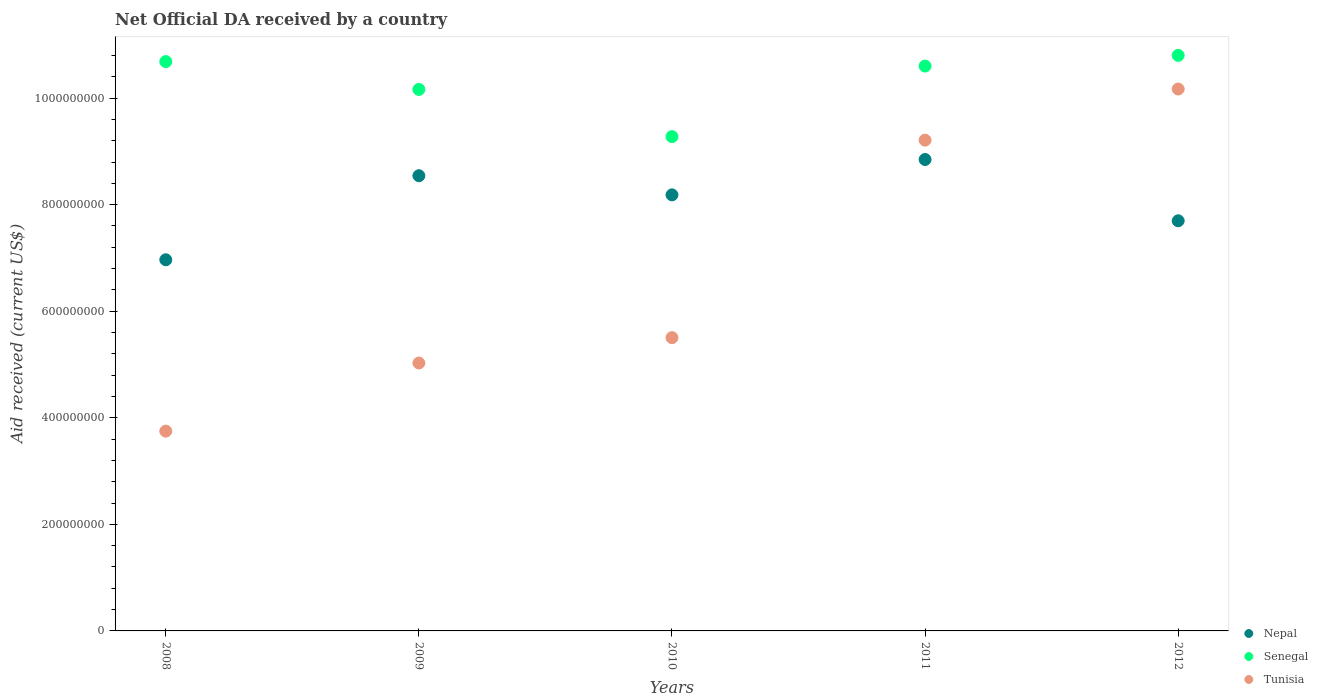What is the net official development assistance aid received in Tunisia in 2011?
Provide a short and direct response. 9.21e+08. Across all years, what is the maximum net official development assistance aid received in Senegal?
Offer a terse response. 1.08e+09. Across all years, what is the minimum net official development assistance aid received in Nepal?
Make the answer very short. 6.97e+08. What is the total net official development assistance aid received in Senegal in the graph?
Ensure brevity in your answer.  5.15e+09. What is the difference between the net official development assistance aid received in Nepal in 2008 and that in 2009?
Provide a short and direct response. -1.58e+08. What is the difference between the net official development assistance aid received in Nepal in 2011 and the net official development assistance aid received in Tunisia in 2010?
Provide a succinct answer. 3.34e+08. What is the average net official development assistance aid received in Nepal per year?
Offer a terse response. 8.05e+08. In the year 2011, what is the difference between the net official development assistance aid received in Senegal and net official development assistance aid received in Nepal?
Give a very brief answer. 1.75e+08. In how many years, is the net official development assistance aid received in Nepal greater than 720000000 US$?
Give a very brief answer. 4. What is the ratio of the net official development assistance aid received in Tunisia in 2009 to that in 2010?
Offer a very short reply. 0.91. What is the difference between the highest and the second highest net official development assistance aid received in Tunisia?
Provide a succinct answer. 9.59e+07. What is the difference between the highest and the lowest net official development assistance aid received in Senegal?
Offer a terse response. 1.52e+08. In how many years, is the net official development assistance aid received in Tunisia greater than the average net official development assistance aid received in Tunisia taken over all years?
Your answer should be compact. 2. Is the sum of the net official development assistance aid received in Senegal in 2011 and 2012 greater than the maximum net official development assistance aid received in Tunisia across all years?
Provide a succinct answer. Yes. Is it the case that in every year, the sum of the net official development assistance aid received in Nepal and net official development assistance aid received in Tunisia  is greater than the net official development assistance aid received in Senegal?
Offer a very short reply. Yes. Is the net official development assistance aid received in Tunisia strictly greater than the net official development assistance aid received in Nepal over the years?
Ensure brevity in your answer.  No. Is the net official development assistance aid received in Tunisia strictly less than the net official development assistance aid received in Nepal over the years?
Make the answer very short. No. How many dotlines are there?
Your answer should be very brief. 3. How many years are there in the graph?
Make the answer very short. 5. What is the difference between two consecutive major ticks on the Y-axis?
Give a very brief answer. 2.00e+08. Does the graph contain grids?
Keep it short and to the point. No. Where does the legend appear in the graph?
Ensure brevity in your answer.  Bottom right. What is the title of the graph?
Offer a terse response. Net Official DA received by a country. Does "Nicaragua" appear as one of the legend labels in the graph?
Your answer should be very brief. No. What is the label or title of the Y-axis?
Give a very brief answer. Aid received (current US$). What is the Aid received (current US$) of Nepal in 2008?
Give a very brief answer. 6.97e+08. What is the Aid received (current US$) in Senegal in 2008?
Give a very brief answer. 1.07e+09. What is the Aid received (current US$) in Tunisia in 2008?
Give a very brief answer. 3.75e+08. What is the Aid received (current US$) in Nepal in 2009?
Ensure brevity in your answer.  8.54e+08. What is the Aid received (current US$) in Senegal in 2009?
Keep it short and to the point. 1.02e+09. What is the Aid received (current US$) in Tunisia in 2009?
Ensure brevity in your answer.  5.03e+08. What is the Aid received (current US$) of Nepal in 2010?
Your response must be concise. 8.18e+08. What is the Aid received (current US$) of Senegal in 2010?
Offer a very short reply. 9.28e+08. What is the Aid received (current US$) of Tunisia in 2010?
Offer a terse response. 5.50e+08. What is the Aid received (current US$) of Nepal in 2011?
Keep it short and to the point. 8.85e+08. What is the Aid received (current US$) of Senegal in 2011?
Offer a terse response. 1.06e+09. What is the Aid received (current US$) of Tunisia in 2011?
Provide a short and direct response. 9.21e+08. What is the Aid received (current US$) in Nepal in 2012?
Your answer should be compact. 7.70e+08. What is the Aid received (current US$) of Senegal in 2012?
Ensure brevity in your answer.  1.08e+09. What is the Aid received (current US$) of Tunisia in 2012?
Ensure brevity in your answer.  1.02e+09. Across all years, what is the maximum Aid received (current US$) in Nepal?
Keep it short and to the point. 8.85e+08. Across all years, what is the maximum Aid received (current US$) in Senegal?
Keep it short and to the point. 1.08e+09. Across all years, what is the maximum Aid received (current US$) in Tunisia?
Ensure brevity in your answer.  1.02e+09. Across all years, what is the minimum Aid received (current US$) in Nepal?
Your answer should be compact. 6.97e+08. Across all years, what is the minimum Aid received (current US$) in Senegal?
Provide a short and direct response. 9.28e+08. Across all years, what is the minimum Aid received (current US$) of Tunisia?
Make the answer very short. 3.75e+08. What is the total Aid received (current US$) in Nepal in the graph?
Make the answer very short. 4.02e+09. What is the total Aid received (current US$) in Senegal in the graph?
Give a very brief answer. 5.15e+09. What is the total Aid received (current US$) of Tunisia in the graph?
Keep it short and to the point. 3.37e+09. What is the difference between the Aid received (current US$) in Nepal in 2008 and that in 2009?
Give a very brief answer. -1.58e+08. What is the difference between the Aid received (current US$) of Senegal in 2008 and that in 2009?
Your response must be concise. 5.23e+07. What is the difference between the Aid received (current US$) in Tunisia in 2008 and that in 2009?
Make the answer very short. -1.28e+08. What is the difference between the Aid received (current US$) of Nepal in 2008 and that in 2010?
Give a very brief answer. -1.22e+08. What is the difference between the Aid received (current US$) in Senegal in 2008 and that in 2010?
Your response must be concise. 1.41e+08. What is the difference between the Aid received (current US$) in Tunisia in 2008 and that in 2010?
Provide a succinct answer. -1.75e+08. What is the difference between the Aid received (current US$) in Nepal in 2008 and that in 2011?
Provide a succinct answer. -1.88e+08. What is the difference between the Aid received (current US$) of Senegal in 2008 and that in 2011?
Keep it short and to the point. 8.43e+06. What is the difference between the Aid received (current US$) of Tunisia in 2008 and that in 2011?
Make the answer very short. -5.46e+08. What is the difference between the Aid received (current US$) in Nepal in 2008 and that in 2012?
Your answer should be very brief. -7.32e+07. What is the difference between the Aid received (current US$) in Senegal in 2008 and that in 2012?
Your response must be concise. -1.17e+07. What is the difference between the Aid received (current US$) in Tunisia in 2008 and that in 2012?
Your response must be concise. -6.42e+08. What is the difference between the Aid received (current US$) of Nepal in 2009 and that in 2010?
Offer a very short reply. 3.60e+07. What is the difference between the Aid received (current US$) of Senegal in 2009 and that in 2010?
Make the answer very short. 8.86e+07. What is the difference between the Aid received (current US$) in Tunisia in 2009 and that in 2010?
Ensure brevity in your answer.  -4.76e+07. What is the difference between the Aid received (current US$) of Nepal in 2009 and that in 2011?
Offer a very short reply. -3.04e+07. What is the difference between the Aid received (current US$) of Senegal in 2009 and that in 2011?
Keep it short and to the point. -4.38e+07. What is the difference between the Aid received (current US$) of Tunisia in 2009 and that in 2011?
Offer a very short reply. -4.18e+08. What is the difference between the Aid received (current US$) of Nepal in 2009 and that in 2012?
Ensure brevity in your answer.  8.46e+07. What is the difference between the Aid received (current US$) of Senegal in 2009 and that in 2012?
Offer a terse response. -6.40e+07. What is the difference between the Aid received (current US$) of Tunisia in 2009 and that in 2012?
Make the answer very short. -5.14e+08. What is the difference between the Aid received (current US$) of Nepal in 2010 and that in 2011?
Your answer should be very brief. -6.64e+07. What is the difference between the Aid received (current US$) in Senegal in 2010 and that in 2011?
Your answer should be compact. -1.32e+08. What is the difference between the Aid received (current US$) of Tunisia in 2010 and that in 2011?
Your response must be concise. -3.71e+08. What is the difference between the Aid received (current US$) of Nepal in 2010 and that in 2012?
Provide a succinct answer. 4.86e+07. What is the difference between the Aid received (current US$) in Senegal in 2010 and that in 2012?
Make the answer very short. -1.52e+08. What is the difference between the Aid received (current US$) of Tunisia in 2010 and that in 2012?
Give a very brief answer. -4.67e+08. What is the difference between the Aid received (current US$) of Nepal in 2011 and that in 2012?
Your answer should be compact. 1.15e+08. What is the difference between the Aid received (current US$) of Senegal in 2011 and that in 2012?
Give a very brief answer. -2.01e+07. What is the difference between the Aid received (current US$) in Tunisia in 2011 and that in 2012?
Give a very brief answer. -9.59e+07. What is the difference between the Aid received (current US$) in Nepal in 2008 and the Aid received (current US$) in Senegal in 2009?
Your answer should be compact. -3.20e+08. What is the difference between the Aid received (current US$) of Nepal in 2008 and the Aid received (current US$) of Tunisia in 2009?
Offer a terse response. 1.94e+08. What is the difference between the Aid received (current US$) of Senegal in 2008 and the Aid received (current US$) of Tunisia in 2009?
Your answer should be very brief. 5.66e+08. What is the difference between the Aid received (current US$) in Nepal in 2008 and the Aid received (current US$) in Senegal in 2010?
Ensure brevity in your answer.  -2.31e+08. What is the difference between the Aid received (current US$) in Nepal in 2008 and the Aid received (current US$) in Tunisia in 2010?
Keep it short and to the point. 1.46e+08. What is the difference between the Aid received (current US$) in Senegal in 2008 and the Aid received (current US$) in Tunisia in 2010?
Give a very brief answer. 5.18e+08. What is the difference between the Aid received (current US$) in Nepal in 2008 and the Aid received (current US$) in Senegal in 2011?
Offer a terse response. -3.64e+08. What is the difference between the Aid received (current US$) of Nepal in 2008 and the Aid received (current US$) of Tunisia in 2011?
Give a very brief answer. -2.25e+08. What is the difference between the Aid received (current US$) in Senegal in 2008 and the Aid received (current US$) in Tunisia in 2011?
Provide a short and direct response. 1.47e+08. What is the difference between the Aid received (current US$) in Nepal in 2008 and the Aid received (current US$) in Senegal in 2012?
Ensure brevity in your answer.  -3.84e+08. What is the difference between the Aid received (current US$) of Nepal in 2008 and the Aid received (current US$) of Tunisia in 2012?
Keep it short and to the point. -3.20e+08. What is the difference between the Aid received (current US$) in Senegal in 2008 and the Aid received (current US$) in Tunisia in 2012?
Make the answer very short. 5.15e+07. What is the difference between the Aid received (current US$) in Nepal in 2009 and the Aid received (current US$) in Senegal in 2010?
Make the answer very short. -7.34e+07. What is the difference between the Aid received (current US$) of Nepal in 2009 and the Aid received (current US$) of Tunisia in 2010?
Your answer should be very brief. 3.04e+08. What is the difference between the Aid received (current US$) in Senegal in 2009 and the Aid received (current US$) in Tunisia in 2010?
Make the answer very short. 4.66e+08. What is the difference between the Aid received (current US$) in Nepal in 2009 and the Aid received (current US$) in Senegal in 2011?
Ensure brevity in your answer.  -2.06e+08. What is the difference between the Aid received (current US$) of Nepal in 2009 and the Aid received (current US$) of Tunisia in 2011?
Give a very brief answer. -6.68e+07. What is the difference between the Aid received (current US$) of Senegal in 2009 and the Aid received (current US$) of Tunisia in 2011?
Provide a short and direct response. 9.52e+07. What is the difference between the Aid received (current US$) in Nepal in 2009 and the Aid received (current US$) in Senegal in 2012?
Make the answer very short. -2.26e+08. What is the difference between the Aid received (current US$) of Nepal in 2009 and the Aid received (current US$) of Tunisia in 2012?
Offer a terse response. -1.63e+08. What is the difference between the Aid received (current US$) in Senegal in 2009 and the Aid received (current US$) in Tunisia in 2012?
Offer a very short reply. -7.90e+05. What is the difference between the Aid received (current US$) in Nepal in 2010 and the Aid received (current US$) in Senegal in 2011?
Keep it short and to the point. -2.42e+08. What is the difference between the Aid received (current US$) in Nepal in 2010 and the Aid received (current US$) in Tunisia in 2011?
Provide a succinct answer. -1.03e+08. What is the difference between the Aid received (current US$) of Senegal in 2010 and the Aid received (current US$) of Tunisia in 2011?
Provide a short and direct response. 6.60e+06. What is the difference between the Aid received (current US$) in Nepal in 2010 and the Aid received (current US$) in Senegal in 2012?
Provide a short and direct response. -2.62e+08. What is the difference between the Aid received (current US$) in Nepal in 2010 and the Aid received (current US$) in Tunisia in 2012?
Your answer should be very brief. -1.99e+08. What is the difference between the Aid received (current US$) of Senegal in 2010 and the Aid received (current US$) of Tunisia in 2012?
Your answer should be very brief. -8.93e+07. What is the difference between the Aid received (current US$) in Nepal in 2011 and the Aid received (current US$) in Senegal in 2012?
Ensure brevity in your answer.  -1.95e+08. What is the difference between the Aid received (current US$) in Nepal in 2011 and the Aid received (current US$) in Tunisia in 2012?
Your answer should be very brief. -1.32e+08. What is the difference between the Aid received (current US$) of Senegal in 2011 and the Aid received (current US$) of Tunisia in 2012?
Provide a succinct answer. 4.31e+07. What is the average Aid received (current US$) of Nepal per year?
Ensure brevity in your answer.  8.05e+08. What is the average Aid received (current US$) in Senegal per year?
Offer a terse response. 1.03e+09. What is the average Aid received (current US$) of Tunisia per year?
Provide a short and direct response. 6.73e+08. In the year 2008, what is the difference between the Aid received (current US$) of Nepal and Aid received (current US$) of Senegal?
Make the answer very short. -3.72e+08. In the year 2008, what is the difference between the Aid received (current US$) of Nepal and Aid received (current US$) of Tunisia?
Keep it short and to the point. 3.22e+08. In the year 2008, what is the difference between the Aid received (current US$) in Senegal and Aid received (current US$) in Tunisia?
Offer a very short reply. 6.94e+08. In the year 2009, what is the difference between the Aid received (current US$) of Nepal and Aid received (current US$) of Senegal?
Provide a short and direct response. -1.62e+08. In the year 2009, what is the difference between the Aid received (current US$) of Nepal and Aid received (current US$) of Tunisia?
Offer a very short reply. 3.52e+08. In the year 2009, what is the difference between the Aid received (current US$) in Senegal and Aid received (current US$) in Tunisia?
Provide a succinct answer. 5.13e+08. In the year 2010, what is the difference between the Aid received (current US$) of Nepal and Aid received (current US$) of Senegal?
Your answer should be compact. -1.09e+08. In the year 2010, what is the difference between the Aid received (current US$) of Nepal and Aid received (current US$) of Tunisia?
Ensure brevity in your answer.  2.68e+08. In the year 2010, what is the difference between the Aid received (current US$) in Senegal and Aid received (current US$) in Tunisia?
Your response must be concise. 3.77e+08. In the year 2011, what is the difference between the Aid received (current US$) of Nepal and Aid received (current US$) of Senegal?
Provide a short and direct response. -1.75e+08. In the year 2011, what is the difference between the Aid received (current US$) in Nepal and Aid received (current US$) in Tunisia?
Your answer should be very brief. -3.63e+07. In the year 2011, what is the difference between the Aid received (current US$) in Senegal and Aid received (current US$) in Tunisia?
Your answer should be very brief. 1.39e+08. In the year 2012, what is the difference between the Aid received (current US$) of Nepal and Aid received (current US$) of Senegal?
Give a very brief answer. -3.10e+08. In the year 2012, what is the difference between the Aid received (current US$) of Nepal and Aid received (current US$) of Tunisia?
Make the answer very short. -2.47e+08. In the year 2012, what is the difference between the Aid received (current US$) of Senegal and Aid received (current US$) of Tunisia?
Provide a short and direct response. 6.32e+07. What is the ratio of the Aid received (current US$) in Nepal in 2008 to that in 2009?
Your response must be concise. 0.82. What is the ratio of the Aid received (current US$) of Senegal in 2008 to that in 2009?
Provide a succinct answer. 1.05. What is the ratio of the Aid received (current US$) of Tunisia in 2008 to that in 2009?
Offer a very short reply. 0.75. What is the ratio of the Aid received (current US$) of Nepal in 2008 to that in 2010?
Keep it short and to the point. 0.85. What is the ratio of the Aid received (current US$) of Senegal in 2008 to that in 2010?
Provide a succinct answer. 1.15. What is the ratio of the Aid received (current US$) of Tunisia in 2008 to that in 2010?
Ensure brevity in your answer.  0.68. What is the ratio of the Aid received (current US$) of Nepal in 2008 to that in 2011?
Provide a succinct answer. 0.79. What is the ratio of the Aid received (current US$) of Tunisia in 2008 to that in 2011?
Provide a short and direct response. 0.41. What is the ratio of the Aid received (current US$) of Nepal in 2008 to that in 2012?
Your answer should be very brief. 0.91. What is the ratio of the Aid received (current US$) in Tunisia in 2008 to that in 2012?
Your answer should be compact. 0.37. What is the ratio of the Aid received (current US$) of Nepal in 2009 to that in 2010?
Give a very brief answer. 1.04. What is the ratio of the Aid received (current US$) in Senegal in 2009 to that in 2010?
Provide a short and direct response. 1.1. What is the ratio of the Aid received (current US$) in Tunisia in 2009 to that in 2010?
Provide a short and direct response. 0.91. What is the ratio of the Aid received (current US$) of Nepal in 2009 to that in 2011?
Make the answer very short. 0.97. What is the ratio of the Aid received (current US$) in Senegal in 2009 to that in 2011?
Offer a very short reply. 0.96. What is the ratio of the Aid received (current US$) of Tunisia in 2009 to that in 2011?
Keep it short and to the point. 0.55. What is the ratio of the Aid received (current US$) of Nepal in 2009 to that in 2012?
Offer a very short reply. 1.11. What is the ratio of the Aid received (current US$) in Senegal in 2009 to that in 2012?
Make the answer very short. 0.94. What is the ratio of the Aid received (current US$) of Tunisia in 2009 to that in 2012?
Offer a terse response. 0.49. What is the ratio of the Aid received (current US$) in Nepal in 2010 to that in 2011?
Offer a terse response. 0.93. What is the ratio of the Aid received (current US$) in Senegal in 2010 to that in 2011?
Your response must be concise. 0.88. What is the ratio of the Aid received (current US$) in Tunisia in 2010 to that in 2011?
Provide a succinct answer. 0.6. What is the ratio of the Aid received (current US$) in Nepal in 2010 to that in 2012?
Ensure brevity in your answer.  1.06. What is the ratio of the Aid received (current US$) in Senegal in 2010 to that in 2012?
Provide a succinct answer. 0.86. What is the ratio of the Aid received (current US$) of Tunisia in 2010 to that in 2012?
Provide a short and direct response. 0.54. What is the ratio of the Aid received (current US$) of Nepal in 2011 to that in 2012?
Provide a short and direct response. 1.15. What is the ratio of the Aid received (current US$) of Senegal in 2011 to that in 2012?
Offer a very short reply. 0.98. What is the ratio of the Aid received (current US$) of Tunisia in 2011 to that in 2012?
Offer a very short reply. 0.91. What is the difference between the highest and the second highest Aid received (current US$) in Nepal?
Provide a short and direct response. 3.04e+07. What is the difference between the highest and the second highest Aid received (current US$) of Senegal?
Keep it short and to the point. 1.17e+07. What is the difference between the highest and the second highest Aid received (current US$) of Tunisia?
Your answer should be very brief. 9.59e+07. What is the difference between the highest and the lowest Aid received (current US$) in Nepal?
Make the answer very short. 1.88e+08. What is the difference between the highest and the lowest Aid received (current US$) of Senegal?
Provide a succinct answer. 1.52e+08. What is the difference between the highest and the lowest Aid received (current US$) in Tunisia?
Provide a short and direct response. 6.42e+08. 